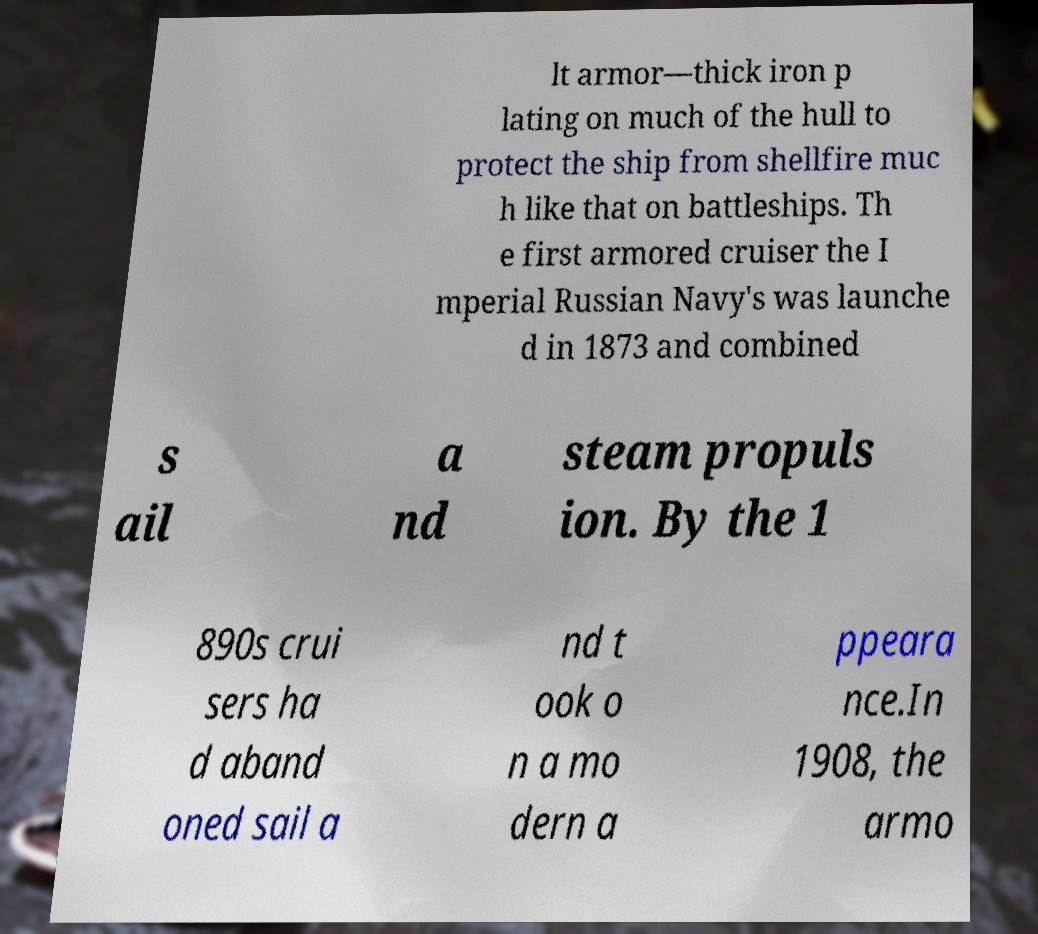Could you assist in decoding the text presented in this image and type it out clearly? lt armor—thick iron p lating on much of the hull to protect the ship from shellfire muc h like that on battleships. Th e first armored cruiser the I mperial Russian Navy's was launche d in 1873 and combined s ail a nd steam propuls ion. By the 1 890s crui sers ha d aband oned sail a nd t ook o n a mo dern a ppeara nce.In 1908, the armo 